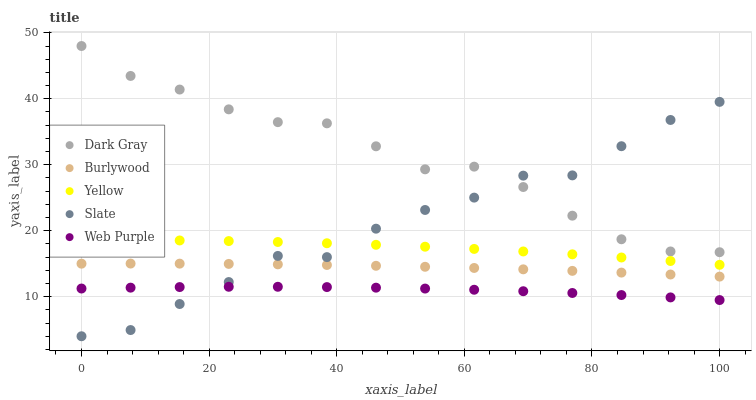Does Web Purple have the minimum area under the curve?
Answer yes or no. Yes. Does Dark Gray have the maximum area under the curve?
Answer yes or no. Yes. Does Burlywood have the minimum area under the curve?
Answer yes or no. No. Does Burlywood have the maximum area under the curve?
Answer yes or no. No. Is Burlywood the smoothest?
Answer yes or no. Yes. Is Slate the roughest?
Answer yes or no. Yes. Is Slate the smoothest?
Answer yes or no. No. Is Burlywood the roughest?
Answer yes or no. No. Does Slate have the lowest value?
Answer yes or no. Yes. Does Burlywood have the lowest value?
Answer yes or no. No. Does Dark Gray have the highest value?
Answer yes or no. Yes. Does Burlywood have the highest value?
Answer yes or no. No. Is Yellow less than Dark Gray?
Answer yes or no. Yes. Is Burlywood greater than Web Purple?
Answer yes or no. Yes. Does Burlywood intersect Slate?
Answer yes or no. Yes. Is Burlywood less than Slate?
Answer yes or no. No. Is Burlywood greater than Slate?
Answer yes or no. No. Does Yellow intersect Dark Gray?
Answer yes or no. No. 